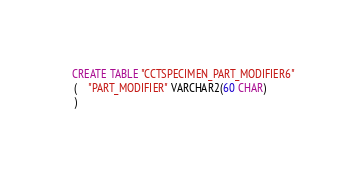<code> <loc_0><loc_0><loc_500><loc_500><_SQL_>
  CREATE TABLE "CCTSPECIMEN_PART_MODIFIER6" 
   (	"PART_MODIFIER" VARCHAR2(60 CHAR)
   ) </code> 